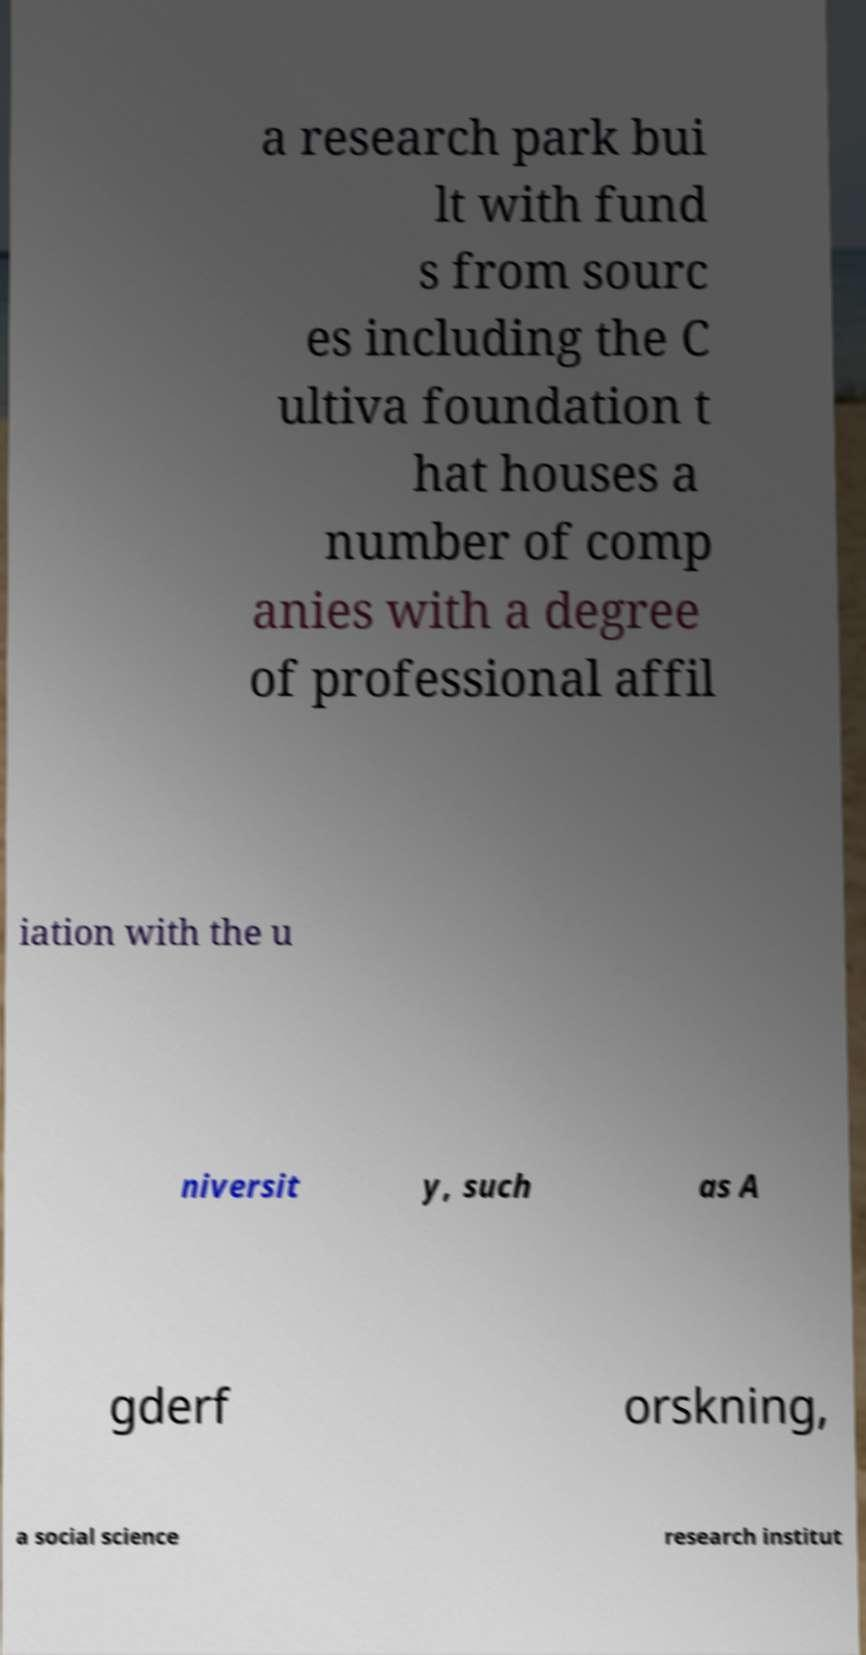Can you read and provide the text displayed in the image?This photo seems to have some interesting text. Can you extract and type it out for me? a research park bui lt with fund s from sourc es including the C ultiva foundation t hat houses a number of comp anies with a degree of professional affil iation with the u niversit y, such as A gderf orskning, a social science research institut 